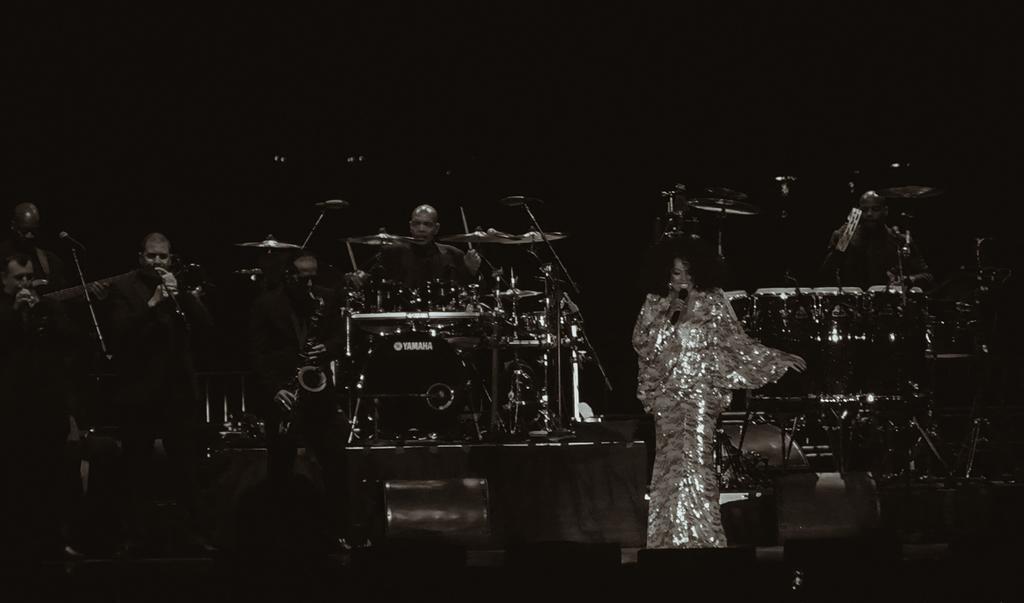Describe this image in one or two sentences. This picture might be taken in a concert, in this image there are some persons who are holding mikes and it seems that they are singing. In the background there are some people who are playing drums, and also there are some drums and some other objects and there is a black background. 